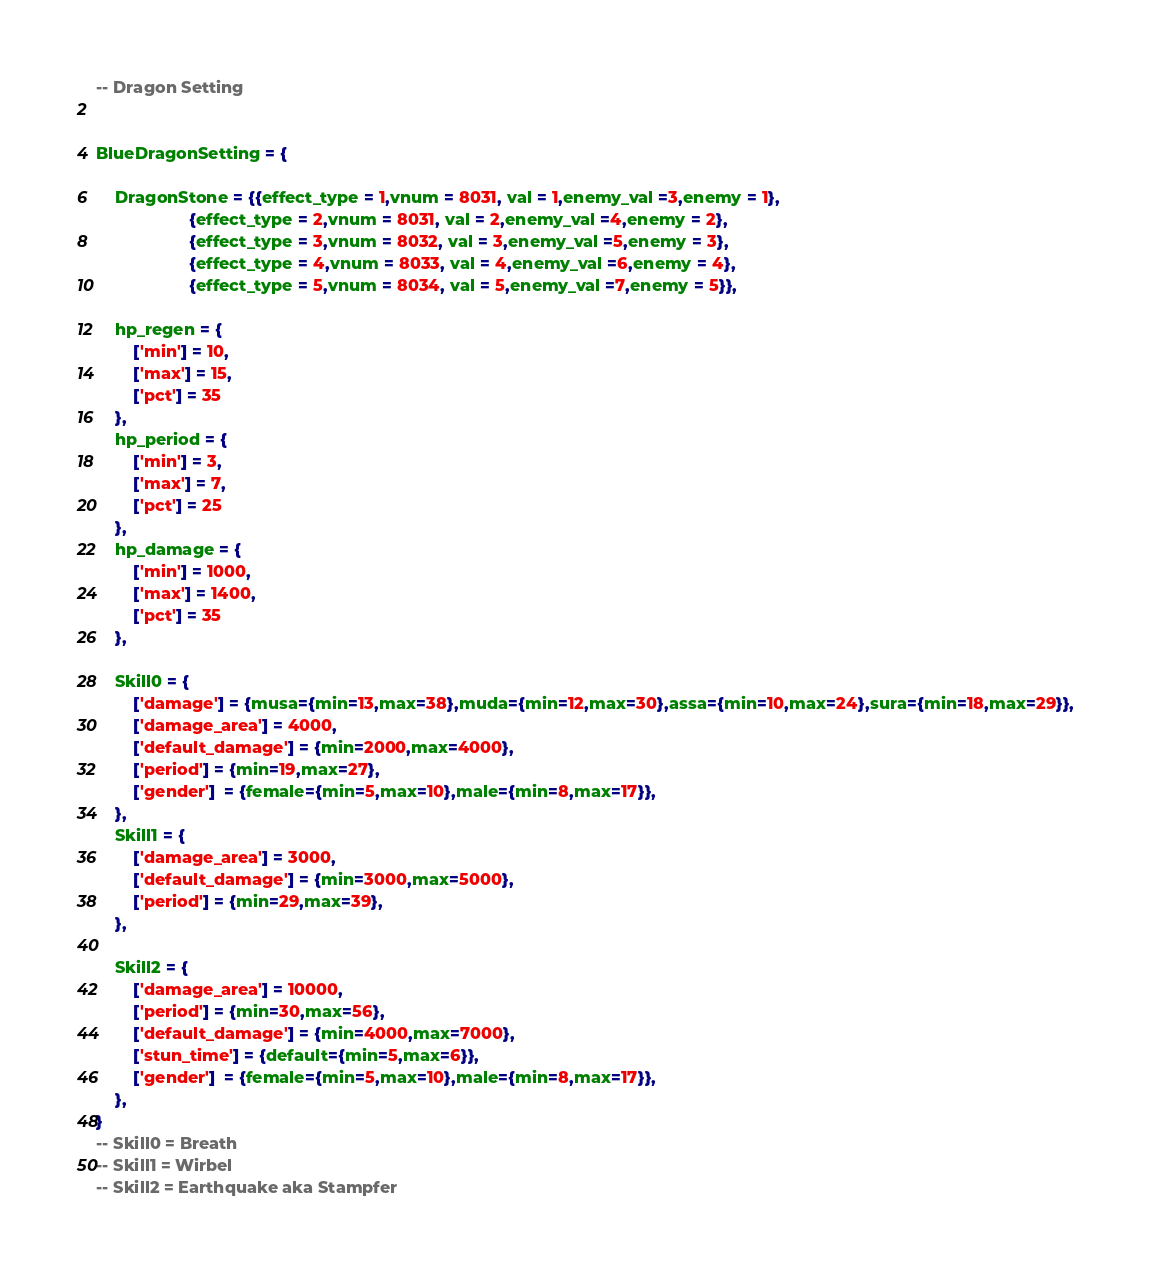<code> <loc_0><loc_0><loc_500><loc_500><_Lua_>-- Dragon Setting


BlueDragonSetting = {
    
    DragonStone = {{effect_type = 1,vnum = 8031, val = 1,enemy_val =3,enemy = 1},
                    {effect_type = 2,vnum = 8031, val = 2,enemy_val =4,enemy = 2},
                    {effect_type = 3,vnum = 8032, val = 3,enemy_val =5,enemy = 3},
                    {effect_type = 4,vnum = 8033, val = 4,enemy_val =6,enemy = 4},
                    {effect_type = 5,vnum = 8034, val = 5,enemy_val =7,enemy = 5}},
        
    hp_regen = {
        ['min'] = 10,
        ['max'] = 15,
        ['pct'] = 35
    },
    hp_period = {
        ['min'] = 3,
        ['max'] = 7,
        ['pct'] = 25
    },
    hp_damage = {
        ['min'] = 1000,
        ['max'] = 1400,
        ['pct'] = 35
    },
    
    Skill0 = {
        ['damage'] = {musa={min=13,max=38},muda={min=12,max=30},assa={min=10,max=24},sura={min=18,max=29}},
        ['damage_area'] = 4000,
        ['default_damage'] = {min=2000,max=4000},
        ['period'] = {min=19,max=27},
        ['gender']  = {female={min=5,max=10},male={min=8,max=17}},
    },
    Skill1 = {
        ['damage_area'] = 3000,
        ['default_damage'] = {min=3000,max=5000},
        ['period'] = {min=29,max=39},
    },
    
    Skill2 = {
        ['damage_area'] = 10000,
        ['period'] = {min=30,max=56},
        ['default_damage'] = {min=4000,max=7000},
        ['stun_time'] = {default={min=5,max=6}},
        ['gender']  = {female={min=5,max=10},male={min=8,max=17}},
    },
}
-- Skill0 = Breath
-- Skill1 = Wirbel
-- Skill2 = Earthquake aka Stampfer  
</code> 